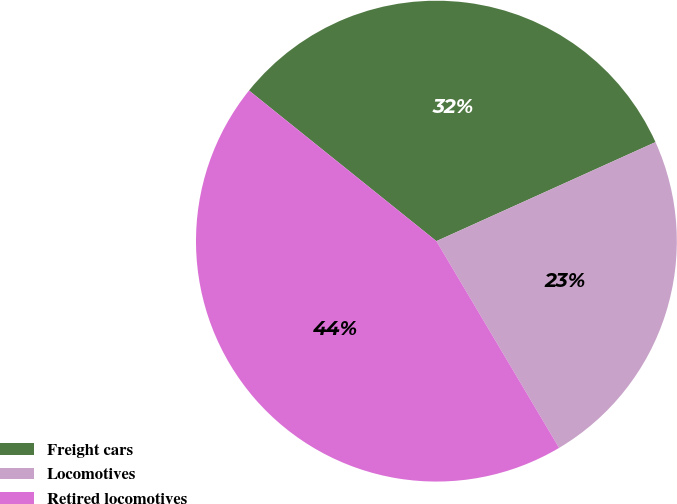<chart> <loc_0><loc_0><loc_500><loc_500><pie_chart><fcel>Freight cars<fcel>Locomotives<fcel>Retired locomotives<nl><fcel>32.47%<fcel>23.23%<fcel>44.3%<nl></chart> 